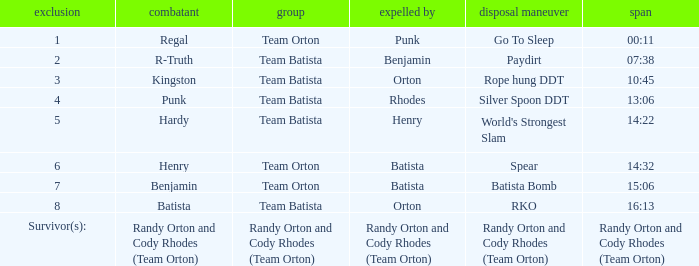What time was the Wrestler Henry eliminated by Batista? 14:32. 